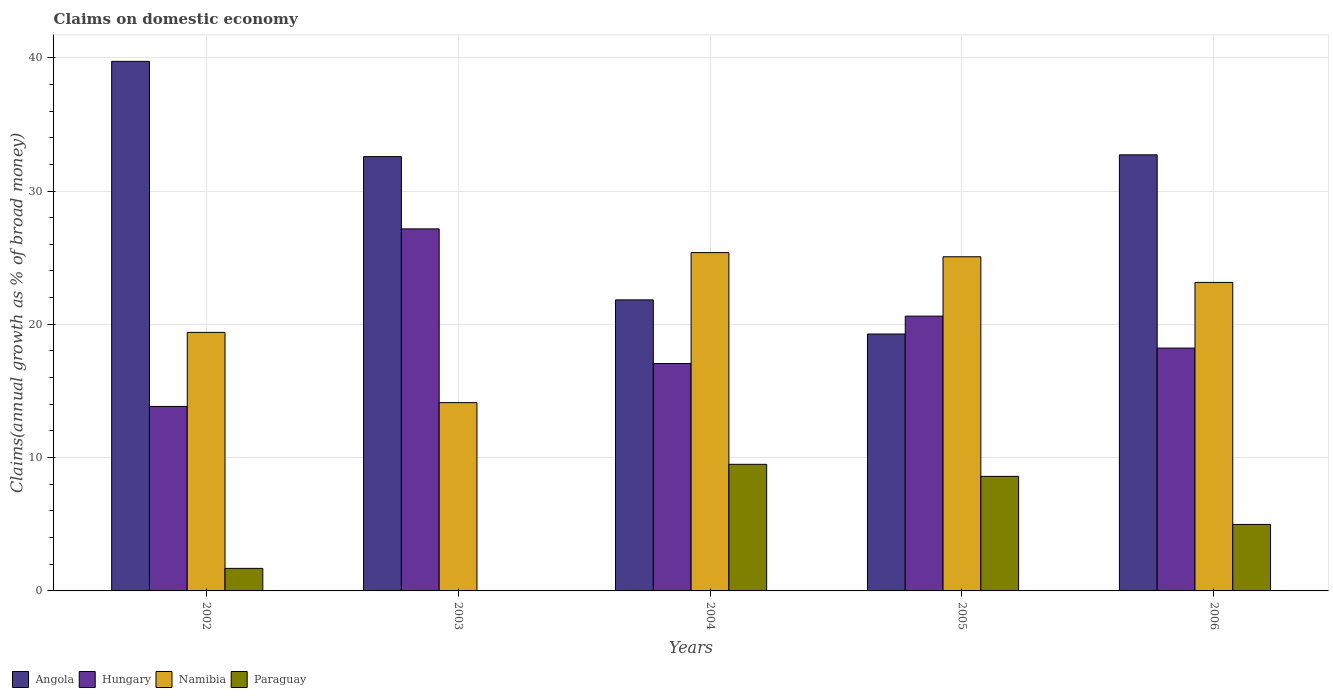How many different coloured bars are there?
Your response must be concise. 4. How many groups of bars are there?
Give a very brief answer. 5. How many bars are there on the 4th tick from the right?
Offer a very short reply. 3. In how many cases, is the number of bars for a given year not equal to the number of legend labels?
Your response must be concise. 1. What is the percentage of broad money claimed on domestic economy in Angola in 2005?
Provide a succinct answer. 19.27. Across all years, what is the maximum percentage of broad money claimed on domestic economy in Hungary?
Offer a very short reply. 27.16. Across all years, what is the minimum percentage of broad money claimed on domestic economy in Namibia?
Your answer should be compact. 14.13. In which year was the percentage of broad money claimed on domestic economy in Paraguay maximum?
Give a very brief answer. 2004. What is the total percentage of broad money claimed on domestic economy in Namibia in the graph?
Keep it short and to the point. 107.11. What is the difference between the percentage of broad money claimed on domestic economy in Namibia in 2002 and that in 2006?
Offer a terse response. -3.75. What is the difference between the percentage of broad money claimed on domestic economy in Paraguay in 2006 and the percentage of broad money claimed on domestic economy in Namibia in 2004?
Provide a succinct answer. -20.39. What is the average percentage of broad money claimed on domestic economy in Angola per year?
Make the answer very short. 29.23. In the year 2005, what is the difference between the percentage of broad money claimed on domestic economy in Namibia and percentage of broad money claimed on domestic economy in Hungary?
Ensure brevity in your answer.  4.45. What is the ratio of the percentage of broad money claimed on domestic economy in Angola in 2002 to that in 2003?
Provide a short and direct response. 1.22. Is the percentage of broad money claimed on domestic economy in Hungary in 2005 less than that in 2006?
Ensure brevity in your answer.  No. Is the difference between the percentage of broad money claimed on domestic economy in Namibia in 2003 and 2006 greater than the difference between the percentage of broad money claimed on domestic economy in Hungary in 2003 and 2006?
Make the answer very short. No. What is the difference between the highest and the second highest percentage of broad money claimed on domestic economy in Paraguay?
Offer a terse response. 0.91. What is the difference between the highest and the lowest percentage of broad money claimed on domestic economy in Angola?
Your response must be concise. 20.45. Is it the case that in every year, the sum of the percentage of broad money claimed on domestic economy in Namibia and percentage of broad money claimed on domestic economy in Paraguay is greater than the percentage of broad money claimed on domestic economy in Hungary?
Ensure brevity in your answer.  No. How many years are there in the graph?
Keep it short and to the point. 5. What is the difference between two consecutive major ticks on the Y-axis?
Give a very brief answer. 10. Does the graph contain grids?
Give a very brief answer. Yes. Where does the legend appear in the graph?
Your answer should be very brief. Bottom left. How many legend labels are there?
Your answer should be very brief. 4. What is the title of the graph?
Make the answer very short. Claims on domestic economy. What is the label or title of the X-axis?
Provide a short and direct response. Years. What is the label or title of the Y-axis?
Keep it short and to the point. Claims(annual growth as % of broad money). What is the Claims(annual growth as % of broad money) in Angola in 2002?
Your answer should be compact. 39.73. What is the Claims(annual growth as % of broad money) of Hungary in 2002?
Your answer should be compact. 13.84. What is the Claims(annual growth as % of broad money) of Namibia in 2002?
Provide a succinct answer. 19.39. What is the Claims(annual growth as % of broad money) of Paraguay in 2002?
Give a very brief answer. 1.69. What is the Claims(annual growth as % of broad money) of Angola in 2003?
Make the answer very short. 32.58. What is the Claims(annual growth as % of broad money) of Hungary in 2003?
Ensure brevity in your answer.  27.16. What is the Claims(annual growth as % of broad money) in Namibia in 2003?
Your response must be concise. 14.13. What is the Claims(annual growth as % of broad money) in Angola in 2004?
Your response must be concise. 21.83. What is the Claims(annual growth as % of broad money) in Hungary in 2004?
Offer a terse response. 17.06. What is the Claims(annual growth as % of broad money) of Namibia in 2004?
Provide a short and direct response. 25.38. What is the Claims(annual growth as % of broad money) in Paraguay in 2004?
Offer a very short reply. 9.5. What is the Claims(annual growth as % of broad money) in Angola in 2005?
Ensure brevity in your answer.  19.27. What is the Claims(annual growth as % of broad money) of Hungary in 2005?
Ensure brevity in your answer.  20.61. What is the Claims(annual growth as % of broad money) in Namibia in 2005?
Provide a succinct answer. 25.07. What is the Claims(annual growth as % of broad money) of Paraguay in 2005?
Provide a succinct answer. 8.59. What is the Claims(annual growth as % of broad money) of Angola in 2006?
Provide a succinct answer. 32.71. What is the Claims(annual growth as % of broad money) of Hungary in 2006?
Your response must be concise. 18.22. What is the Claims(annual growth as % of broad money) of Namibia in 2006?
Your answer should be compact. 23.14. What is the Claims(annual growth as % of broad money) of Paraguay in 2006?
Your answer should be very brief. 4.99. Across all years, what is the maximum Claims(annual growth as % of broad money) of Angola?
Offer a terse response. 39.73. Across all years, what is the maximum Claims(annual growth as % of broad money) in Hungary?
Offer a terse response. 27.16. Across all years, what is the maximum Claims(annual growth as % of broad money) in Namibia?
Provide a short and direct response. 25.38. Across all years, what is the maximum Claims(annual growth as % of broad money) in Paraguay?
Provide a succinct answer. 9.5. Across all years, what is the minimum Claims(annual growth as % of broad money) in Angola?
Your response must be concise. 19.27. Across all years, what is the minimum Claims(annual growth as % of broad money) in Hungary?
Offer a very short reply. 13.84. Across all years, what is the minimum Claims(annual growth as % of broad money) of Namibia?
Your answer should be compact. 14.13. What is the total Claims(annual growth as % of broad money) in Angola in the graph?
Provide a short and direct response. 146.13. What is the total Claims(annual growth as % of broad money) of Hungary in the graph?
Your answer should be compact. 96.89. What is the total Claims(annual growth as % of broad money) of Namibia in the graph?
Offer a very short reply. 107.11. What is the total Claims(annual growth as % of broad money) of Paraguay in the graph?
Your answer should be very brief. 24.77. What is the difference between the Claims(annual growth as % of broad money) of Angola in 2002 and that in 2003?
Provide a short and direct response. 7.15. What is the difference between the Claims(annual growth as % of broad money) in Hungary in 2002 and that in 2003?
Offer a very short reply. -13.32. What is the difference between the Claims(annual growth as % of broad money) in Namibia in 2002 and that in 2003?
Provide a succinct answer. 5.27. What is the difference between the Claims(annual growth as % of broad money) in Angola in 2002 and that in 2004?
Provide a succinct answer. 17.89. What is the difference between the Claims(annual growth as % of broad money) of Hungary in 2002 and that in 2004?
Give a very brief answer. -3.22. What is the difference between the Claims(annual growth as % of broad money) of Namibia in 2002 and that in 2004?
Your answer should be compact. -5.98. What is the difference between the Claims(annual growth as % of broad money) of Paraguay in 2002 and that in 2004?
Keep it short and to the point. -7.81. What is the difference between the Claims(annual growth as % of broad money) of Angola in 2002 and that in 2005?
Provide a succinct answer. 20.45. What is the difference between the Claims(annual growth as % of broad money) of Hungary in 2002 and that in 2005?
Give a very brief answer. -6.78. What is the difference between the Claims(annual growth as % of broad money) of Namibia in 2002 and that in 2005?
Your response must be concise. -5.67. What is the difference between the Claims(annual growth as % of broad money) in Paraguay in 2002 and that in 2005?
Provide a succinct answer. -6.9. What is the difference between the Claims(annual growth as % of broad money) of Angola in 2002 and that in 2006?
Offer a terse response. 7.01. What is the difference between the Claims(annual growth as % of broad money) of Hungary in 2002 and that in 2006?
Your response must be concise. -4.38. What is the difference between the Claims(annual growth as % of broad money) of Namibia in 2002 and that in 2006?
Your answer should be compact. -3.75. What is the difference between the Claims(annual growth as % of broad money) of Paraguay in 2002 and that in 2006?
Offer a terse response. -3.3. What is the difference between the Claims(annual growth as % of broad money) in Angola in 2003 and that in 2004?
Give a very brief answer. 10.75. What is the difference between the Claims(annual growth as % of broad money) in Hungary in 2003 and that in 2004?
Provide a short and direct response. 10.1. What is the difference between the Claims(annual growth as % of broad money) in Namibia in 2003 and that in 2004?
Your answer should be compact. -11.25. What is the difference between the Claims(annual growth as % of broad money) of Angola in 2003 and that in 2005?
Provide a succinct answer. 13.31. What is the difference between the Claims(annual growth as % of broad money) of Hungary in 2003 and that in 2005?
Provide a short and direct response. 6.55. What is the difference between the Claims(annual growth as % of broad money) of Namibia in 2003 and that in 2005?
Your answer should be compact. -10.94. What is the difference between the Claims(annual growth as % of broad money) of Angola in 2003 and that in 2006?
Ensure brevity in your answer.  -0.13. What is the difference between the Claims(annual growth as % of broad money) in Hungary in 2003 and that in 2006?
Provide a short and direct response. 8.94. What is the difference between the Claims(annual growth as % of broad money) in Namibia in 2003 and that in 2006?
Provide a succinct answer. -9.02. What is the difference between the Claims(annual growth as % of broad money) of Angola in 2004 and that in 2005?
Offer a very short reply. 2.56. What is the difference between the Claims(annual growth as % of broad money) in Hungary in 2004 and that in 2005?
Your answer should be very brief. -3.56. What is the difference between the Claims(annual growth as % of broad money) of Namibia in 2004 and that in 2005?
Make the answer very short. 0.31. What is the difference between the Claims(annual growth as % of broad money) of Paraguay in 2004 and that in 2005?
Ensure brevity in your answer.  0.91. What is the difference between the Claims(annual growth as % of broad money) in Angola in 2004 and that in 2006?
Provide a succinct answer. -10.88. What is the difference between the Claims(annual growth as % of broad money) of Hungary in 2004 and that in 2006?
Ensure brevity in your answer.  -1.16. What is the difference between the Claims(annual growth as % of broad money) of Namibia in 2004 and that in 2006?
Your answer should be very brief. 2.24. What is the difference between the Claims(annual growth as % of broad money) of Paraguay in 2004 and that in 2006?
Make the answer very short. 4.51. What is the difference between the Claims(annual growth as % of broad money) of Angola in 2005 and that in 2006?
Offer a terse response. -13.44. What is the difference between the Claims(annual growth as % of broad money) in Hungary in 2005 and that in 2006?
Your response must be concise. 2.4. What is the difference between the Claims(annual growth as % of broad money) in Namibia in 2005 and that in 2006?
Provide a short and direct response. 1.93. What is the difference between the Claims(annual growth as % of broad money) of Paraguay in 2005 and that in 2006?
Your answer should be very brief. 3.6. What is the difference between the Claims(annual growth as % of broad money) of Angola in 2002 and the Claims(annual growth as % of broad money) of Hungary in 2003?
Your answer should be very brief. 12.57. What is the difference between the Claims(annual growth as % of broad money) of Angola in 2002 and the Claims(annual growth as % of broad money) of Namibia in 2003?
Provide a succinct answer. 25.6. What is the difference between the Claims(annual growth as % of broad money) in Hungary in 2002 and the Claims(annual growth as % of broad money) in Namibia in 2003?
Give a very brief answer. -0.29. What is the difference between the Claims(annual growth as % of broad money) of Angola in 2002 and the Claims(annual growth as % of broad money) of Hungary in 2004?
Make the answer very short. 22.67. What is the difference between the Claims(annual growth as % of broad money) in Angola in 2002 and the Claims(annual growth as % of broad money) in Namibia in 2004?
Your answer should be very brief. 14.35. What is the difference between the Claims(annual growth as % of broad money) in Angola in 2002 and the Claims(annual growth as % of broad money) in Paraguay in 2004?
Make the answer very short. 30.23. What is the difference between the Claims(annual growth as % of broad money) in Hungary in 2002 and the Claims(annual growth as % of broad money) in Namibia in 2004?
Offer a terse response. -11.54. What is the difference between the Claims(annual growth as % of broad money) of Hungary in 2002 and the Claims(annual growth as % of broad money) of Paraguay in 2004?
Keep it short and to the point. 4.34. What is the difference between the Claims(annual growth as % of broad money) of Namibia in 2002 and the Claims(annual growth as % of broad money) of Paraguay in 2004?
Your response must be concise. 9.9. What is the difference between the Claims(annual growth as % of broad money) of Angola in 2002 and the Claims(annual growth as % of broad money) of Hungary in 2005?
Make the answer very short. 19.11. What is the difference between the Claims(annual growth as % of broad money) of Angola in 2002 and the Claims(annual growth as % of broad money) of Namibia in 2005?
Keep it short and to the point. 14.66. What is the difference between the Claims(annual growth as % of broad money) of Angola in 2002 and the Claims(annual growth as % of broad money) of Paraguay in 2005?
Your answer should be very brief. 31.13. What is the difference between the Claims(annual growth as % of broad money) in Hungary in 2002 and the Claims(annual growth as % of broad money) in Namibia in 2005?
Your response must be concise. -11.23. What is the difference between the Claims(annual growth as % of broad money) in Hungary in 2002 and the Claims(annual growth as % of broad money) in Paraguay in 2005?
Offer a very short reply. 5.25. What is the difference between the Claims(annual growth as % of broad money) in Namibia in 2002 and the Claims(annual growth as % of broad money) in Paraguay in 2005?
Keep it short and to the point. 10.8. What is the difference between the Claims(annual growth as % of broad money) in Angola in 2002 and the Claims(annual growth as % of broad money) in Hungary in 2006?
Make the answer very short. 21.51. What is the difference between the Claims(annual growth as % of broad money) of Angola in 2002 and the Claims(annual growth as % of broad money) of Namibia in 2006?
Make the answer very short. 16.58. What is the difference between the Claims(annual growth as % of broad money) in Angola in 2002 and the Claims(annual growth as % of broad money) in Paraguay in 2006?
Offer a very short reply. 34.74. What is the difference between the Claims(annual growth as % of broad money) in Hungary in 2002 and the Claims(annual growth as % of broad money) in Namibia in 2006?
Your response must be concise. -9.3. What is the difference between the Claims(annual growth as % of broad money) of Hungary in 2002 and the Claims(annual growth as % of broad money) of Paraguay in 2006?
Offer a very short reply. 8.85. What is the difference between the Claims(annual growth as % of broad money) in Namibia in 2002 and the Claims(annual growth as % of broad money) in Paraguay in 2006?
Make the answer very short. 14.41. What is the difference between the Claims(annual growth as % of broad money) of Angola in 2003 and the Claims(annual growth as % of broad money) of Hungary in 2004?
Provide a short and direct response. 15.52. What is the difference between the Claims(annual growth as % of broad money) of Angola in 2003 and the Claims(annual growth as % of broad money) of Namibia in 2004?
Ensure brevity in your answer.  7.2. What is the difference between the Claims(annual growth as % of broad money) in Angola in 2003 and the Claims(annual growth as % of broad money) in Paraguay in 2004?
Your answer should be compact. 23.08. What is the difference between the Claims(annual growth as % of broad money) of Hungary in 2003 and the Claims(annual growth as % of broad money) of Namibia in 2004?
Your answer should be very brief. 1.78. What is the difference between the Claims(annual growth as % of broad money) of Hungary in 2003 and the Claims(annual growth as % of broad money) of Paraguay in 2004?
Provide a succinct answer. 17.66. What is the difference between the Claims(annual growth as % of broad money) of Namibia in 2003 and the Claims(annual growth as % of broad money) of Paraguay in 2004?
Your response must be concise. 4.63. What is the difference between the Claims(annual growth as % of broad money) in Angola in 2003 and the Claims(annual growth as % of broad money) in Hungary in 2005?
Provide a succinct answer. 11.97. What is the difference between the Claims(annual growth as % of broad money) in Angola in 2003 and the Claims(annual growth as % of broad money) in Namibia in 2005?
Provide a short and direct response. 7.51. What is the difference between the Claims(annual growth as % of broad money) in Angola in 2003 and the Claims(annual growth as % of broad money) in Paraguay in 2005?
Offer a very short reply. 23.99. What is the difference between the Claims(annual growth as % of broad money) in Hungary in 2003 and the Claims(annual growth as % of broad money) in Namibia in 2005?
Give a very brief answer. 2.09. What is the difference between the Claims(annual growth as % of broad money) of Hungary in 2003 and the Claims(annual growth as % of broad money) of Paraguay in 2005?
Provide a short and direct response. 18.57. What is the difference between the Claims(annual growth as % of broad money) of Namibia in 2003 and the Claims(annual growth as % of broad money) of Paraguay in 2005?
Your answer should be compact. 5.53. What is the difference between the Claims(annual growth as % of broad money) in Angola in 2003 and the Claims(annual growth as % of broad money) in Hungary in 2006?
Offer a very short reply. 14.36. What is the difference between the Claims(annual growth as % of broad money) in Angola in 2003 and the Claims(annual growth as % of broad money) in Namibia in 2006?
Make the answer very short. 9.44. What is the difference between the Claims(annual growth as % of broad money) in Angola in 2003 and the Claims(annual growth as % of broad money) in Paraguay in 2006?
Ensure brevity in your answer.  27.59. What is the difference between the Claims(annual growth as % of broad money) of Hungary in 2003 and the Claims(annual growth as % of broad money) of Namibia in 2006?
Provide a short and direct response. 4.02. What is the difference between the Claims(annual growth as % of broad money) in Hungary in 2003 and the Claims(annual growth as % of broad money) in Paraguay in 2006?
Ensure brevity in your answer.  22.17. What is the difference between the Claims(annual growth as % of broad money) in Namibia in 2003 and the Claims(annual growth as % of broad money) in Paraguay in 2006?
Your response must be concise. 9.14. What is the difference between the Claims(annual growth as % of broad money) of Angola in 2004 and the Claims(annual growth as % of broad money) of Hungary in 2005?
Provide a succinct answer. 1.22. What is the difference between the Claims(annual growth as % of broad money) of Angola in 2004 and the Claims(annual growth as % of broad money) of Namibia in 2005?
Offer a terse response. -3.24. What is the difference between the Claims(annual growth as % of broad money) in Angola in 2004 and the Claims(annual growth as % of broad money) in Paraguay in 2005?
Make the answer very short. 13.24. What is the difference between the Claims(annual growth as % of broad money) in Hungary in 2004 and the Claims(annual growth as % of broad money) in Namibia in 2005?
Offer a very short reply. -8.01. What is the difference between the Claims(annual growth as % of broad money) in Hungary in 2004 and the Claims(annual growth as % of broad money) in Paraguay in 2005?
Provide a short and direct response. 8.47. What is the difference between the Claims(annual growth as % of broad money) of Namibia in 2004 and the Claims(annual growth as % of broad money) of Paraguay in 2005?
Provide a succinct answer. 16.79. What is the difference between the Claims(annual growth as % of broad money) of Angola in 2004 and the Claims(annual growth as % of broad money) of Hungary in 2006?
Your answer should be very brief. 3.62. What is the difference between the Claims(annual growth as % of broad money) in Angola in 2004 and the Claims(annual growth as % of broad money) in Namibia in 2006?
Provide a succinct answer. -1.31. What is the difference between the Claims(annual growth as % of broad money) of Angola in 2004 and the Claims(annual growth as % of broad money) of Paraguay in 2006?
Give a very brief answer. 16.84. What is the difference between the Claims(annual growth as % of broad money) of Hungary in 2004 and the Claims(annual growth as % of broad money) of Namibia in 2006?
Give a very brief answer. -6.08. What is the difference between the Claims(annual growth as % of broad money) in Hungary in 2004 and the Claims(annual growth as % of broad money) in Paraguay in 2006?
Make the answer very short. 12.07. What is the difference between the Claims(annual growth as % of broad money) of Namibia in 2004 and the Claims(annual growth as % of broad money) of Paraguay in 2006?
Give a very brief answer. 20.39. What is the difference between the Claims(annual growth as % of broad money) in Angola in 2005 and the Claims(annual growth as % of broad money) in Hungary in 2006?
Ensure brevity in your answer.  1.06. What is the difference between the Claims(annual growth as % of broad money) in Angola in 2005 and the Claims(annual growth as % of broad money) in Namibia in 2006?
Your answer should be very brief. -3.87. What is the difference between the Claims(annual growth as % of broad money) in Angola in 2005 and the Claims(annual growth as % of broad money) in Paraguay in 2006?
Your response must be concise. 14.28. What is the difference between the Claims(annual growth as % of broad money) in Hungary in 2005 and the Claims(annual growth as % of broad money) in Namibia in 2006?
Ensure brevity in your answer.  -2.53. What is the difference between the Claims(annual growth as % of broad money) in Hungary in 2005 and the Claims(annual growth as % of broad money) in Paraguay in 2006?
Your answer should be compact. 15.63. What is the difference between the Claims(annual growth as % of broad money) of Namibia in 2005 and the Claims(annual growth as % of broad money) of Paraguay in 2006?
Your answer should be compact. 20.08. What is the average Claims(annual growth as % of broad money) in Angola per year?
Your answer should be very brief. 29.23. What is the average Claims(annual growth as % of broad money) in Hungary per year?
Offer a very short reply. 19.38. What is the average Claims(annual growth as % of broad money) in Namibia per year?
Provide a succinct answer. 21.42. What is the average Claims(annual growth as % of broad money) of Paraguay per year?
Ensure brevity in your answer.  4.95. In the year 2002, what is the difference between the Claims(annual growth as % of broad money) in Angola and Claims(annual growth as % of broad money) in Hungary?
Provide a short and direct response. 25.89. In the year 2002, what is the difference between the Claims(annual growth as % of broad money) of Angola and Claims(annual growth as % of broad money) of Namibia?
Ensure brevity in your answer.  20.33. In the year 2002, what is the difference between the Claims(annual growth as % of broad money) in Angola and Claims(annual growth as % of broad money) in Paraguay?
Provide a short and direct response. 38.03. In the year 2002, what is the difference between the Claims(annual growth as % of broad money) of Hungary and Claims(annual growth as % of broad money) of Namibia?
Provide a succinct answer. -5.56. In the year 2002, what is the difference between the Claims(annual growth as % of broad money) in Hungary and Claims(annual growth as % of broad money) in Paraguay?
Your response must be concise. 12.15. In the year 2002, what is the difference between the Claims(annual growth as % of broad money) in Namibia and Claims(annual growth as % of broad money) in Paraguay?
Offer a terse response. 17.7. In the year 2003, what is the difference between the Claims(annual growth as % of broad money) in Angola and Claims(annual growth as % of broad money) in Hungary?
Your response must be concise. 5.42. In the year 2003, what is the difference between the Claims(annual growth as % of broad money) in Angola and Claims(annual growth as % of broad money) in Namibia?
Your response must be concise. 18.45. In the year 2003, what is the difference between the Claims(annual growth as % of broad money) in Hungary and Claims(annual growth as % of broad money) in Namibia?
Ensure brevity in your answer.  13.03. In the year 2004, what is the difference between the Claims(annual growth as % of broad money) in Angola and Claims(annual growth as % of broad money) in Hungary?
Make the answer very short. 4.77. In the year 2004, what is the difference between the Claims(annual growth as % of broad money) of Angola and Claims(annual growth as % of broad money) of Namibia?
Provide a succinct answer. -3.55. In the year 2004, what is the difference between the Claims(annual growth as % of broad money) in Angola and Claims(annual growth as % of broad money) in Paraguay?
Offer a terse response. 12.34. In the year 2004, what is the difference between the Claims(annual growth as % of broad money) of Hungary and Claims(annual growth as % of broad money) of Namibia?
Your answer should be compact. -8.32. In the year 2004, what is the difference between the Claims(annual growth as % of broad money) in Hungary and Claims(annual growth as % of broad money) in Paraguay?
Offer a very short reply. 7.56. In the year 2004, what is the difference between the Claims(annual growth as % of broad money) of Namibia and Claims(annual growth as % of broad money) of Paraguay?
Your answer should be very brief. 15.88. In the year 2005, what is the difference between the Claims(annual growth as % of broad money) of Angola and Claims(annual growth as % of broad money) of Hungary?
Offer a terse response. -1.34. In the year 2005, what is the difference between the Claims(annual growth as % of broad money) in Angola and Claims(annual growth as % of broad money) in Namibia?
Keep it short and to the point. -5.79. In the year 2005, what is the difference between the Claims(annual growth as % of broad money) in Angola and Claims(annual growth as % of broad money) in Paraguay?
Your answer should be very brief. 10.68. In the year 2005, what is the difference between the Claims(annual growth as % of broad money) in Hungary and Claims(annual growth as % of broad money) in Namibia?
Your response must be concise. -4.45. In the year 2005, what is the difference between the Claims(annual growth as % of broad money) of Hungary and Claims(annual growth as % of broad money) of Paraguay?
Provide a succinct answer. 12.02. In the year 2005, what is the difference between the Claims(annual growth as % of broad money) in Namibia and Claims(annual growth as % of broad money) in Paraguay?
Provide a short and direct response. 16.48. In the year 2006, what is the difference between the Claims(annual growth as % of broad money) in Angola and Claims(annual growth as % of broad money) in Hungary?
Your response must be concise. 14.5. In the year 2006, what is the difference between the Claims(annual growth as % of broad money) in Angola and Claims(annual growth as % of broad money) in Namibia?
Keep it short and to the point. 9.57. In the year 2006, what is the difference between the Claims(annual growth as % of broad money) of Angola and Claims(annual growth as % of broad money) of Paraguay?
Provide a succinct answer. 27.73. In the year 2006, what is the difference between the Claims(annual growth as % of broad money) of Hungary and Claims(annual growth as % of broad money) of Namibia?
Your response must be concise. -4.92. In the year 2006, what is the difference between the Claims(annual growth as % of broad money) of Hungary and Claims(annual growth as % of broad money) of Paraguay?
Your response must be concise. 13.23. In the year 2006, what is the difference between the Claims(annual growth as % of broad money) of Namibia and Claims(annual growth as % of broad money) of Paraguay?
Your answer should be very brief. 18.15. What is the ratio of the Claims(annual growth as % of broad money) in Angola in 2002 to that in 2003?
Make the answer very short. 1.22. What is the ratio of the Claims(annual growth as % of broad money) of Hungary in 2002 to that in 2003?
Give a very brief answer. 0.51. What is the ratio of the Claims(annual growth as % of broad money) of Namibia in 2002 to that in 2003?
Your response must be concise. 1.37. What is the ratio of the Claims(annual growth as % of broad money) in Angola in 2002 to that in 2004?
Ensure brevity in your answer.  1.82. What is the ratio of the Claims(annual growth as % of broad money) in Hungary in 2002 to that in 2004?
Give a very brief answer. 0.81. What is the ratio of the Claims(annual growth as % of broad money) of Namibia in 2002 to that in 2004?
Keep it short and to the point. 0.76. What is the ratio of the Claims(annual growth as % of broad money) in Paraguay in 2002 to that in 2004?
Provide a short and direct response. 0.18. What is the ratio of the Claims(annual growth as % of broad money) of Angola in 2002 to that in 2005?
Make the answer very short. 2.06. What is the ratio of the Claims(annual growth as % of broad money) in Hungary in 2002 to that in 2005?
Offer a terse response. 0.67. What is the ratio of the Claims(annual growth as % of broad money) of Namibia in 2002 to that in 2005?
Your response must be concise. 0.77. What is the ratio of the Claims(annual growth as % of broad money) of Paraguay in 2002 to that in 2005?
Ensure brevity in your answer.  0.2. What is the ratio of the Claims(annual growth as % of broad money) in Angola in 2002 to that in 2006?
Keep it short and to the point. 1.21. What is the ratio of the Claims(annual growth as % of broad money) of Hungary in 2002 to that in 2006?
Give a very brief answer. 0.76. What is the ratio of the Claims(annual growth as % of broad money) of Namibia in 2002 to that in 2006?
Provide a succinct answer. 0.84. What is the ratio of the Claims(annual growth as % of broad money) of Paraguay in 2002 to that in 2006?
Provide a short and direct response. 0.34. What is the ratio of the Claims(annual growth as % of broad money) of Angola in 2003 to that in 2004?
Make the answer very short. 1.49. What is the ratio of the Claims(annual growth as % of broad money) of Hungary in 2003 to that in 2004?
Your answer should be very brief. 1.59. What is the ratio of the Claims(annual growth as % of broad money) in Namibia in 2003 to that in 2004?
Keep it short and to the point. 0.56. What is the ratio of the Claims(annual growth as % of broad money) in Angola in 2003 to that in 2005?
Offer a terse response. 1.69. What is the ratio of the Claims(annual growth as % of broad money) in Hungary in 2003 to that in 2005?
Make the answer very short. 1.32. What is the ratio of the Claims(annual growth as % of broad money) of Namibia in 2003 to that in 2005?
Your answer should be compact. 0.56. What is the ratio of the Claims(annual growth as % of broad money) in Angola in 2003 to that in 2006?
Your response must be concise. 1. What is the ratio of the Claims(annual growth as % of broad money) of Hungary in 2003 to that in 2006?
Your response must be concise. 1.49. What is the ratio of the Claims(annual growth as % of broad money) in Namibia in 2003 to that in 2006?
Your answer should be very brief. 0.61. What is the ratio of the Claims(annual growth as % of broad money) in Angola in 2004 to that in 2005?
Your answer should be very brief. 1.13. What is the ratio of the Claims(annual growth as % of broad money) in Hungary in 2004 to that in 2005?
Offer a terse response. 0.83. What is the ratio of the Claims(annual growth as % of broad money) in Namibia in 2004 to that in 2005?
Offer a terse response. 1.01. What is the ratio of the Claims(annual growth as % of broad money) of Paraguay in 2004 to that in 2005?
Offer a terse response. 1.11. What is the ratio of the Claims(annual growth as % of broad money) in Angola in 2004 to that in 2006?
Give a very brief answer. 0.67. What is the ratio of the Claims(annual growth as % of broad money) in Hungary in 2004 to that in 2006?
Give a very brief answer. 0.94. What is the ratio of the Claims(annual growth as % of broad money) in Namibia in 2004 to that in 2006?
Offer a terse response. 1.1. What is the ratio of the Claims(annual growth as % of broad money) of Paraguay in 2004 to that in 2006?
Your answer should be compact. 1.9. What is the ratio of the Claims(annual growth as % of broad money) of Angola in 2005 to that in 2006?
Your answer should be compact. 0.59. What is the ratio of the Claims(annual growth as % of broad money) of Hungary in 2005 to that in 2006?
Give a very brief answer. 1.13. What is the ratio of the Claims(annual growth as % of broad money) in Namibia in 2005 to that in 2006?
Make the answer very short. 1.08. What is the ratio of the Claims(annual growth as % of broad money) of Paraguay in 2005 to that in 2006?
Offer a very short reply. 1.72. What is the difference between the highest and the second highest Claims(annual growth as % of broad money) in Angola?
Keep it short and to the point. 7.01. What is the difference between the highest and the second highest Claims(annual growth as % of broad money) in Hungary?
Ensure brevity in your answer.  6.55. What is the difference between the highest and the second highest Claims(annual growth as % of broad money) in Namibia?
Give a very brief answer. 0.31. What is the difference between the highest and the second highest Claims(annual growth as % of broad money) of Paraguay?
Make the answer very short. 0.91. What is the difference between the highest and the lowest Claims(annual growth as % of broad money) of Angola?
Your response must be concise. 20.45. What is the difference between the highest and the lowest Claims(annual growth as % of broad money) of Hungary?
Offer a very short reply. 13.32. What is the difference between the highest and the lowest Claims(annual growth as % of broad money) in Namibia?
Ensure brevity in your answer.  11.25. What is the difference between the highest and the lowest Claims(annual growth as % of broad money) of Paraguay?
Keep it short and to the point. 9.5. 